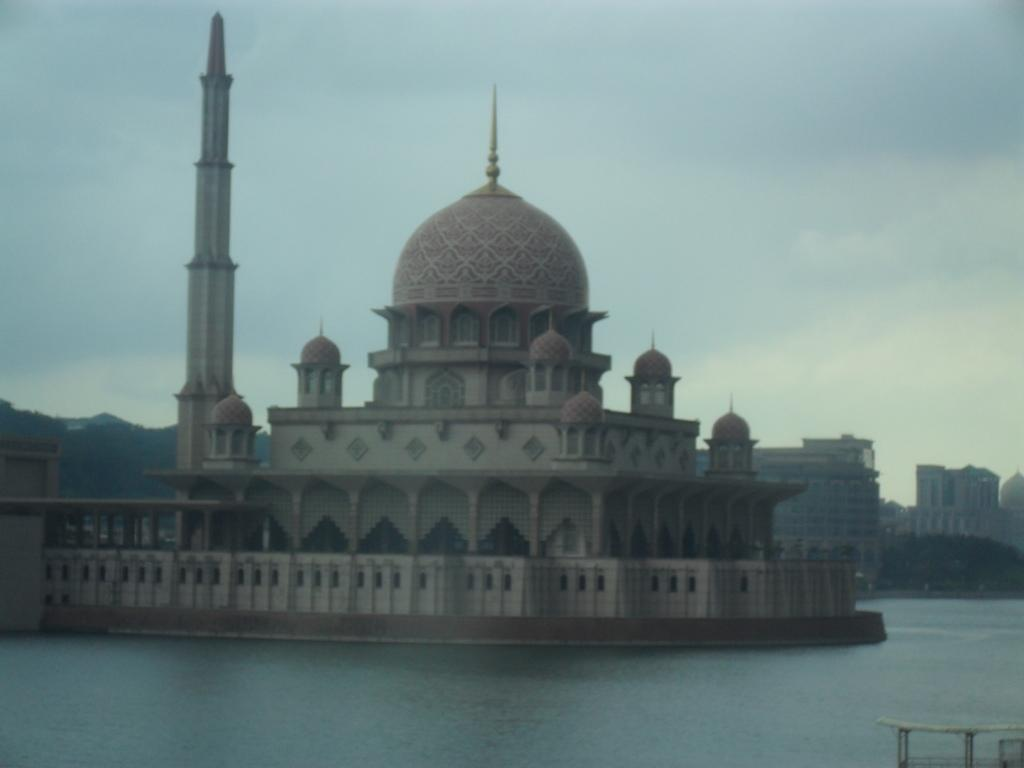What is the main structure in the image? There is a Putra Mosque in the image. What can be seen at the bottom of the image? There is water visible at the bottom of the image. What is located on the right side of the image? There are buildings and trees on the right side of the image. What is visible in the background of the image? The sky is visible in the background of the image. How many deer can be seen grazing near the Putra Mosque in the image? There are no deer present in the image. What type of plate is being used to serve food at the mosque in the image? There is no plate visible in the image, as it is focused on the mosque and surrounding environment. 